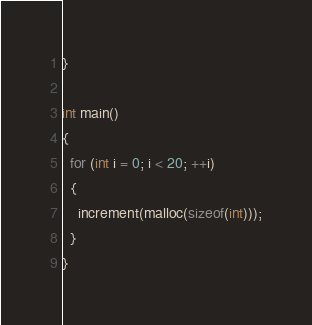<code> <loc_0><loc_0><loc_500><loc_500><_C_>}

int main()
{
  for (int i = 0; i < 20; ++i)
  {
    increment(malloc(sizeof(int)));
  }
}
</code> 